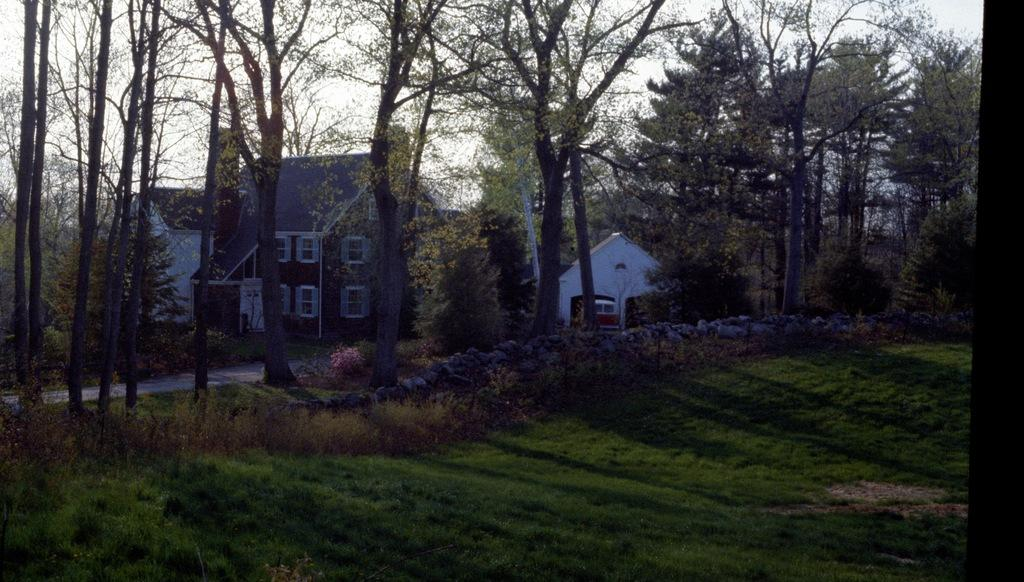What type of vegetation is present at the bottom of the image? There is grass and shrubs at the bottom of the image. What can be seen in the background of the image? There are trees and buildings in the background of the image. What type of material is visible in the image? Stones are visible in the image. What type of surface is present in the image? There is a pavement in the image. What color is the lipstick on the person's shirt in the image? There is no person or shirt present in the image, so there is no lipstick to describe. How much ice is visible in the image? There is no ice present in the image. 